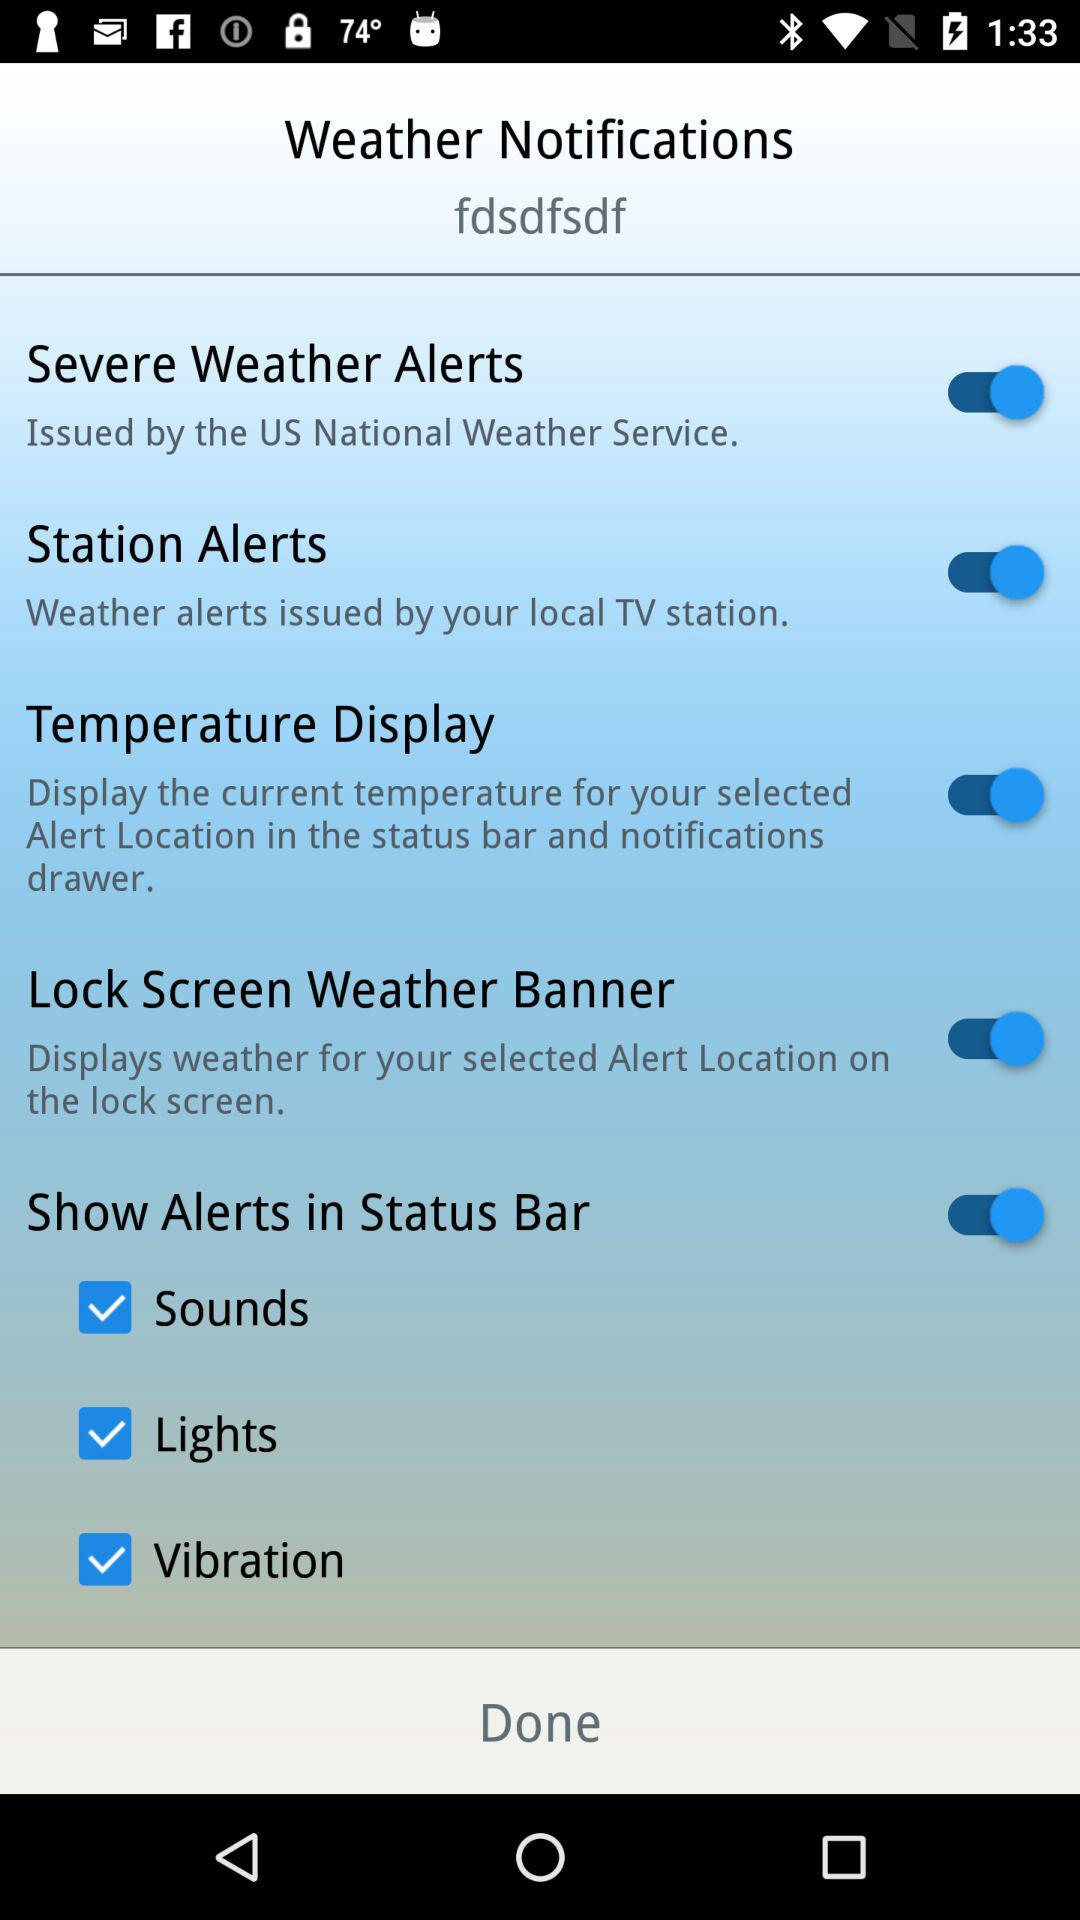What is the status of "Station Alerts"? The status is on. 